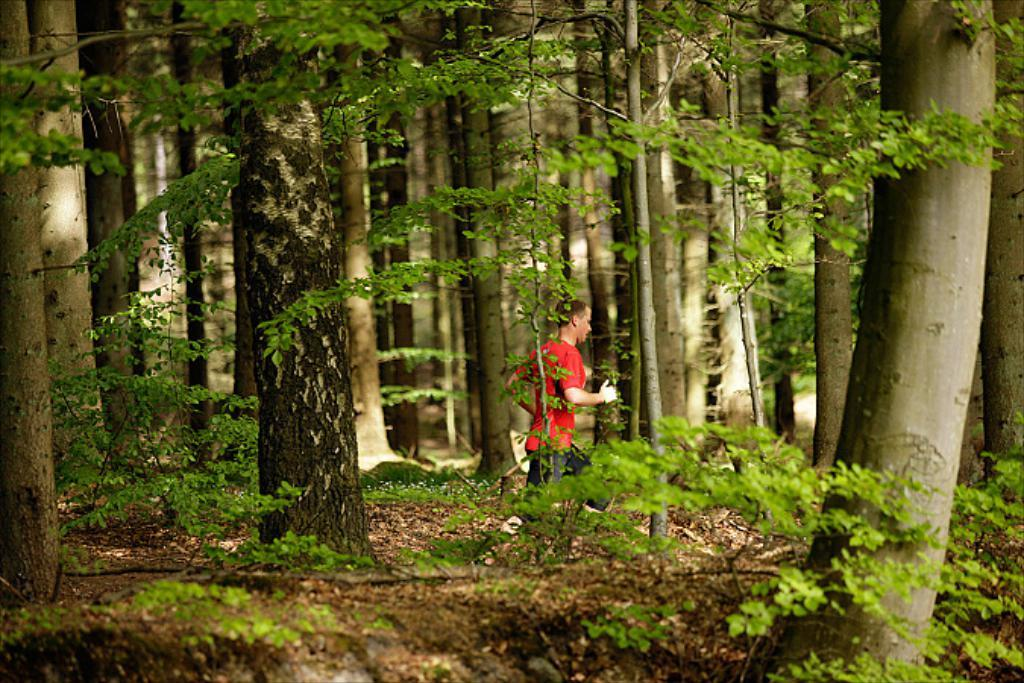What type of vegetation can be seen in the image? There are big trees and small plants in the image. What is the man in the image doing? The man is running in the image. What type of zinc can be seen in the image? There is no zinc present in the image. How does the sea affect the man's running in the image? There is no sea present in the image, so it does not affect the man's running. 